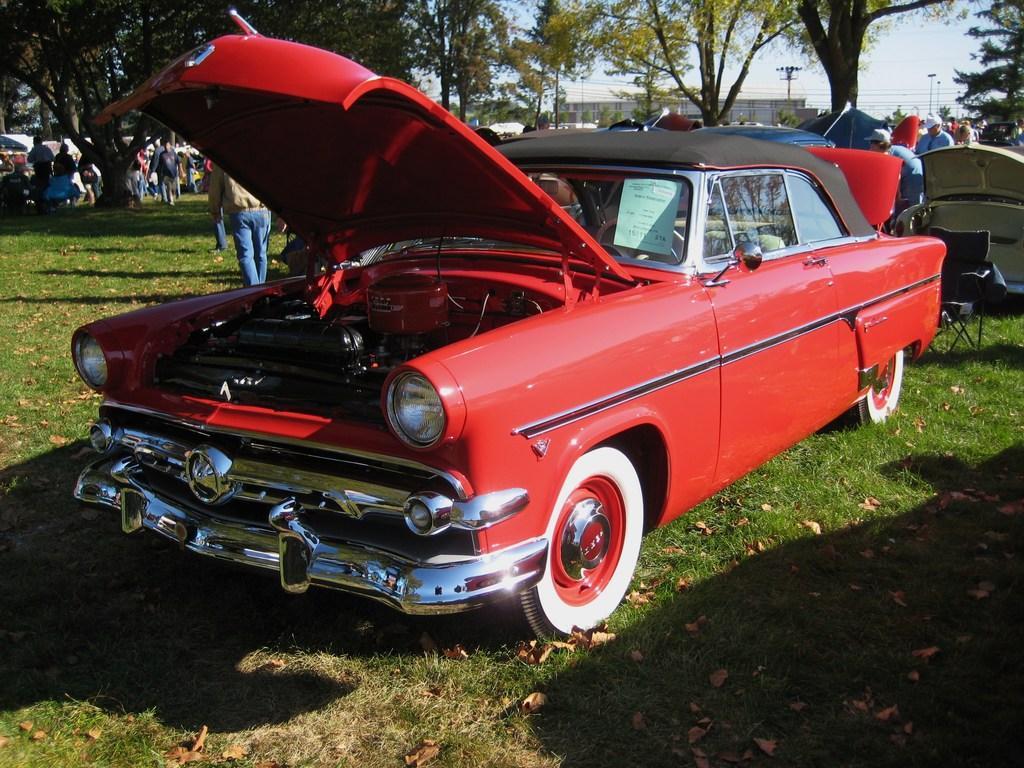Describe this image in one or two sentences. In front of the image there are cars. On the right side of the image there is a chair. At the bottom of the image there is grass and there are dried leaves on the surface. There are people. In the background of the image there are trees, buildings, current poles. At the top of the image there is sky. 